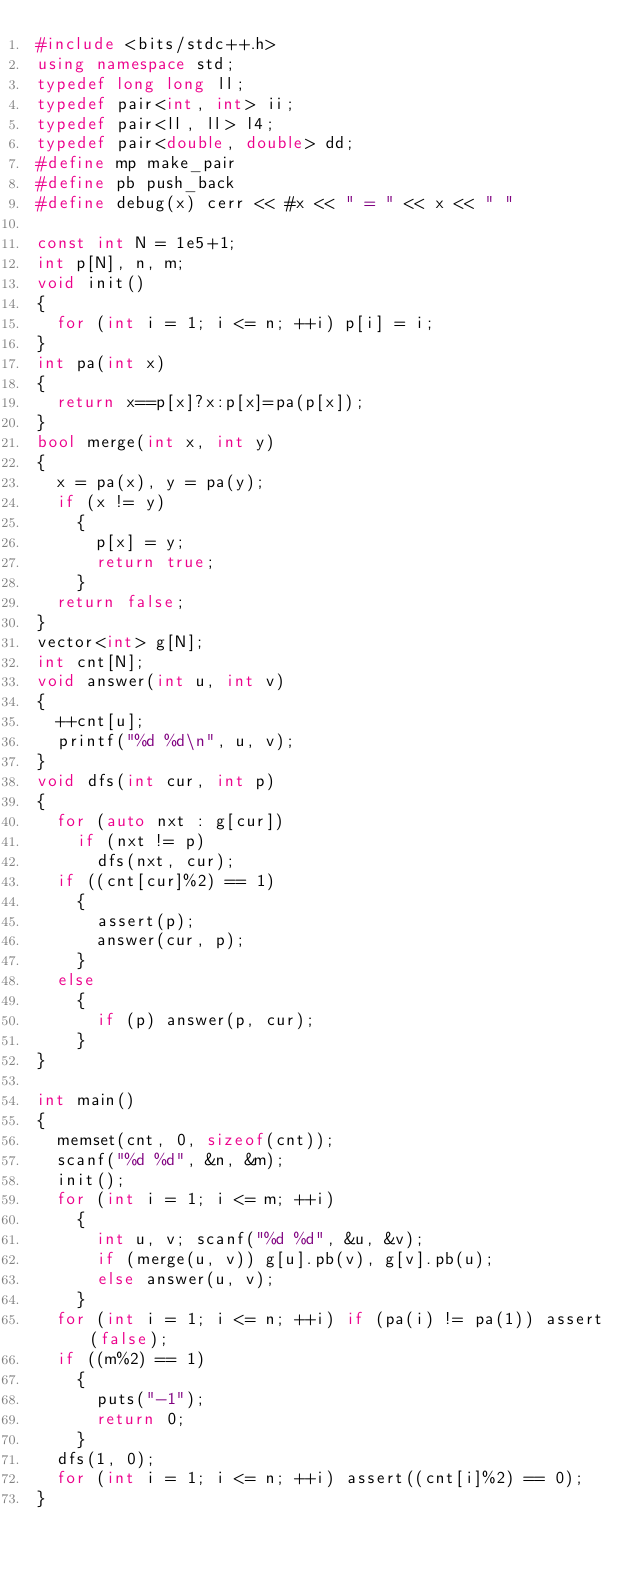Convert code to text. <code><loc_0><loc_0><loc_500><loc_500><_C++_>#include <bits/stdc++.h>
using namespace std;
typedef long long ll;
typedef pair<int, int> ii;
typedef pair<ll, ll> l4;
typedef pair<double, double> dd;
#define mp make_pair
#define pb push_back
#define debug(x) cerr << #x << " = " << x << " "

const int N = 1e5+1;
int p[N], n, m;
void init()
{
  for (int i = 1; i <= n; ++i) p[i] = i;
}
int pa(int x)
{
  return x==p[x]?x:p[x]=pa(p[x]);
}
bool merge(int x, int y)
{
  x = pa(x), y = pa(y);
  if (x != y)
    {
      p[x] = y;
      return true;
    }
  return false;
}
vector<int> g[N];
int cnt[N];
void answer(int u, int v)
{
  ++cnt[u];
  printf("%d %d\n", u, v);
}
void dfs(int cur, int p)
{
  for (auto nxt : g[cur])
    if (nxt != p)
      dfs(nxt, cur);
  if ((cnt[cur]%2) == 1)
    {
      assert(p);
      answer(cur, p);
    }
  else
    {
      if (p) answer(p, cur);
    }
}
  
int main()
{
  memset(cnt, 0, sizeof(cnt));
  scanf("%d %d", &n, &m);
  init();
  for (int i = 1; i <= m; ++i)
    {
      int u, v; scanf("%d %d", &u, &v);
      if (merge(u, v)) g[u].pb(v), g[v].pb(u);
      else answer(u, v);
    }
  for (int i = 1; i <= n; ++i) if (pa(i) != pa(1)) assert(false);
  if ((m%2) == 1)
    {
      puts("-1");
      return 0;
    }
  dfs(1, 0);
  for (int i = 1; i <= n; ++i) assert((cnt[i]%2) == 0);
}
</code> 